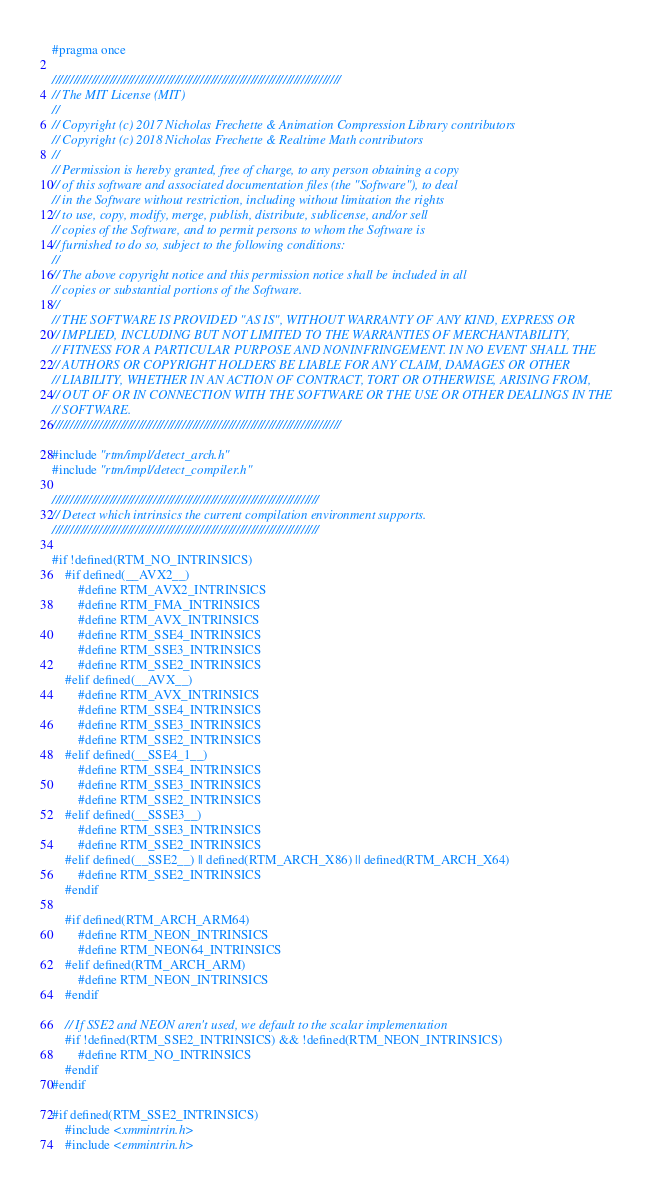Convert code to text. <code><loc_0><loc_0><loc_500><loc_500><_C_>#pragma once

////////////////////////////////////////////////////////////////////////////////
// The MIT License (MIT)
//
// Copyright (c) 2017 Nicholas Frechette & Animation Compression Library contributors
// Copyright (c) 2018 Nicholas Frechette & Realtime Math contributors
//
// Permission is hereby granted, free of charge, to any person obtaining a copy
// of this software and associated documentation files (the "Software"), to deal
// in the Software without restriction, including without limitation the rights
// to use, copy, modify, merge, publish, distribute, sublicense, and/or sell
// copies of the Software, and to permit persons to whom the Software is
// furnished to do so, subject to the following conditions:
//
// The above copyright notice and this permission notice shall be included in all
// copies or substantial portions of the Software.
//
// THE SOFTWARE IS PROVIDED "AS IS", WITHOUT WARRANTY OF ANY KIND, EXPRESS OR
// IMPLIED, INCLUDING BUT NOT LIMITED TO THE WARRANTIES OF MERCHANTABILITY,
// FITNESS FOR A PARTICULAR PURPOSE AND NONINFRINGEMENT. IN NO EVENT SHALL THE
// AUTHORS OR COPYRIGHT HOLDERS BE LIABLE FOR ANY CLAIM, DAMAGES OR OTHER
// LIABILITY, WHETHER IN AN ACTION OF CONTRACT, TORT OR OTHERWISE, ARISING FROM,
// OUT OF OR IN CONNECTION WITH THE SOFTWARE OR THE USE OR OTHER DEALINGS IN THE
// SOFTWARE.
////////////////////////////////////////////////////////////////////////////////

#include "rtm/impl/detect_arch.h"
#include "rtm/impl/detect_compiler.h"

//////////////////////////////////////////////////////////////////////////
// Detect which intrinsics the current compilation environment supports.
//////////////////////////////////////////////////////////////////////////

#if !defined(RTM_NO_INTRINSICS)
	#if defined(__AVX2__)
		#define RTM_AVX2_INTRINSICS
		#define RTM_FMA_INTRINSICS
		#define RTM_AVX_INTRINSICS
		#define RTM_SSE4_INTRINSICS
		#define RTM_SSE3_INTRINSICS
		#define RTM_SSE2_INTRINSICS
	#elif defined(__AVX__)
		#define RTM_AVX_INTRINSICS
		#define RTM_SSE4_INTRINSICS
		#define RTM_SSE3_INTRINSICS
		#define RTM_SSE2_INTRINSICS
	#elif defined(__SSE4_1__)
		#define RTM_SSE4_INTRINSICS
		#define RTM_SSE3_INTRINSICS
		#define RTM_SSE2_INTRINSICS
	#elif defined(__SSSE3__)
		#define RTM_SSE3_INTRINSICS
		#define RTM_SSE2_INTRINSICS
	#elif defined(__SSE2__) || defined(RTM_ARCH_X86) || defined(RTM_ARCH_X64)
		#define RTM_SSE2_INTRINSICS
	#endif

	#if defined(RTM_ARCH_ARM64)
		#define RTM_NEON_INTRINSICS
		#define RTM_NEON64_INTRINSICS
	#elif defined(RTM_ARCH_ARM)
		#define RTM_NEON_INTRINSICS
	#endif

	// If SSE2 and NEON aren't used, we default to the scalar implementation
	#if !defined(RTM_SSE2_INTRINSICS) && !defined(RTM_NEON_INTRINSICS)
		#define RTM_NO_INTRINSICS
	#endif
#endif

#if defined(RTM_SSE2_INTRINSICS)
	#include <xmmintrin.h>
	#include <emmintrin.h>
</code> 